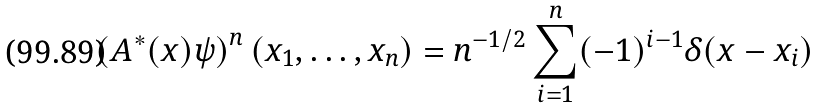<formula> <loc_0><loc_0><loc_500><loc_500>\left ( A ^ { * } ( x ) \psi \right ) ^ { n } ( x _ { 1 } , \dots , x _ { n } ) = n ^ { - 1 / 2 } \sum ^ { n } _ { i = 1 } ( - 1 ) ^ { i - 1 } \delta ( x - x _ { i } )</formula> 